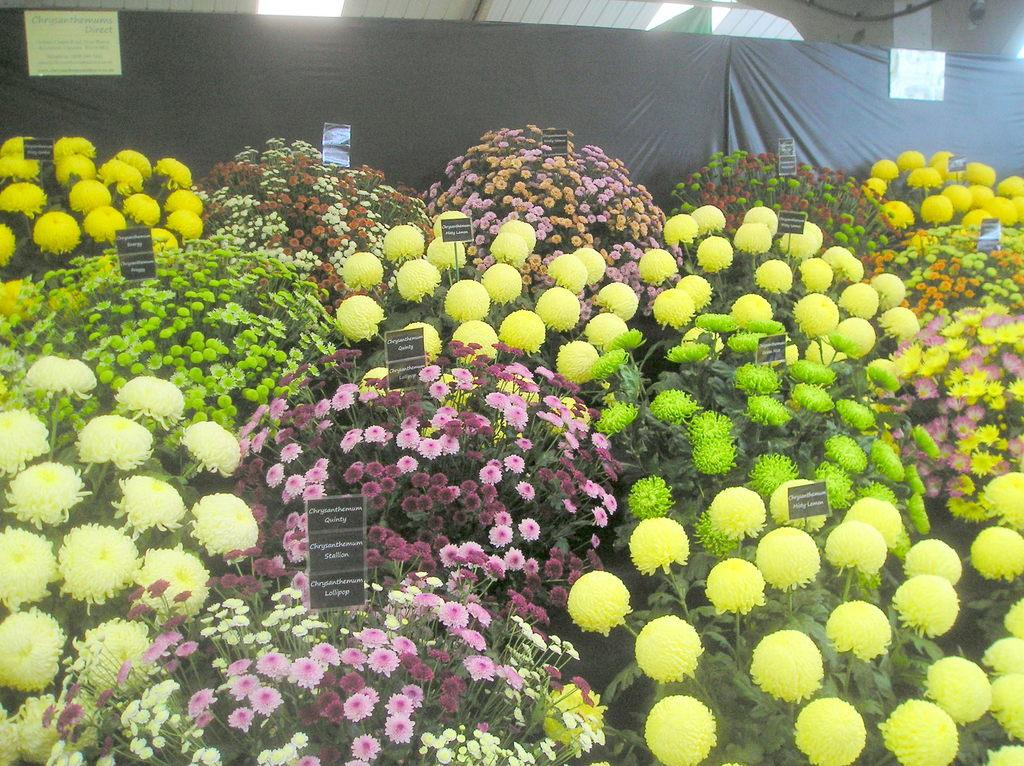What type of plants can be seen in the image? There are plants with flowers in the image. What other objects are present in the image besides the plants? There are boards in the image. What can be seen in the background of the image? There is a banner in the background of the image. Can you hear the ringing of the wishing well in the image? There is no mention of a wishing well or any ringing sound in the image, so it cannot be heard. 